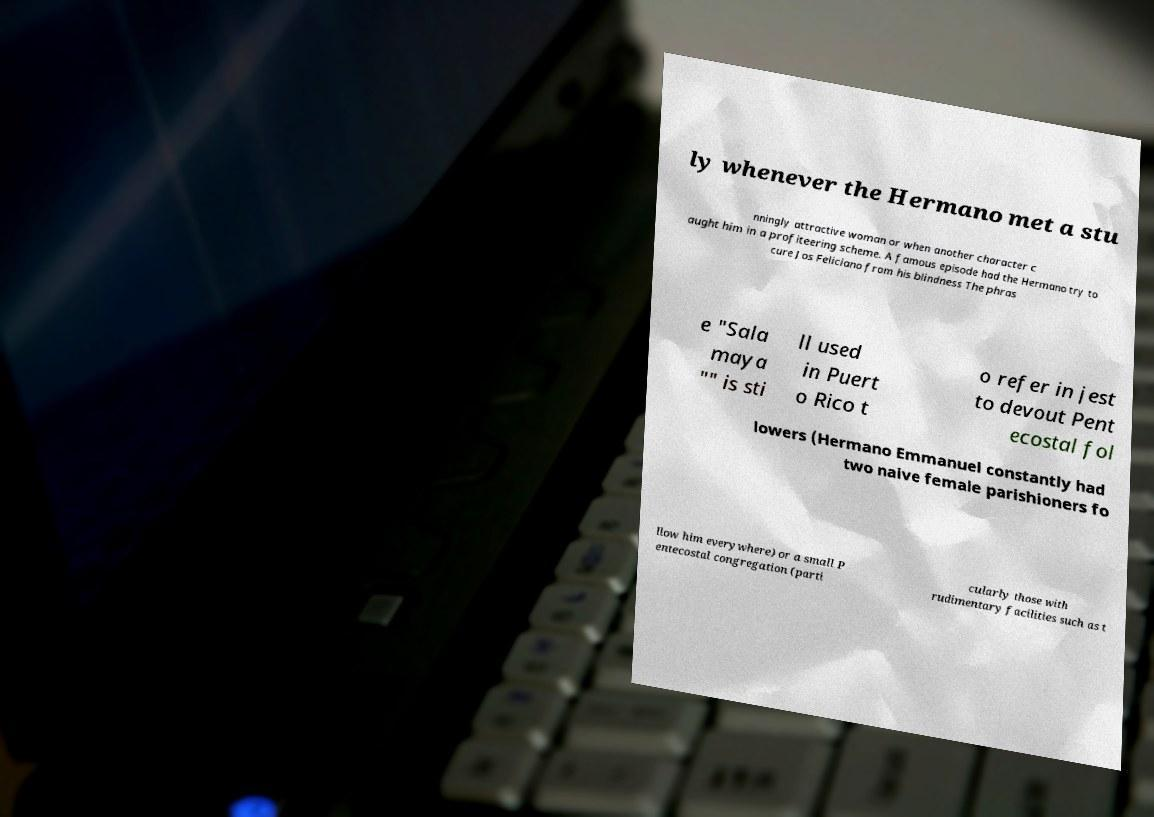Please read and relay the text visible in this image. What does it say? ly whenever the Hermano met a stu nningly attractive woman or when another character c aught him in a profiteering scheme. A famous episode had the Hermano try to cure Jos Feliciano from his blindness The phras e "Sala maya "" is sti ll used in Puert o Rico t o refer in jest to devout Pent ecostal fol lowers (Hermano Emmanuel constantly had two naive female parishioners fo llow him everywhere) or a small P entecostal congregation (parti cularly those with rudimentary facilities such as t 